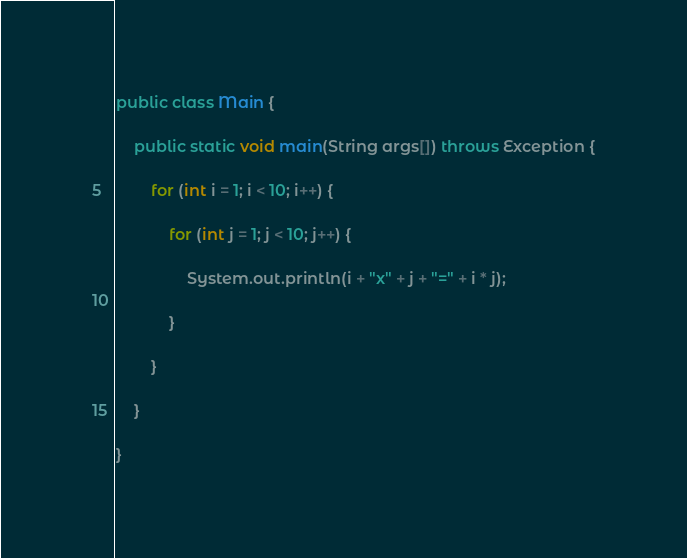Convert code to text. <code><loc_0><loc_0><loc_500><loc_500><_Java_>public class Main {

	public static void main(String args[]) throws Exception {

		for (int i = 1; i < 10; i++) {

			for (int j = 1; j < 10; j++) {

				System.out.println(i + "x" + j + "=" + i * j);

			}

		}

	}

}</code> 